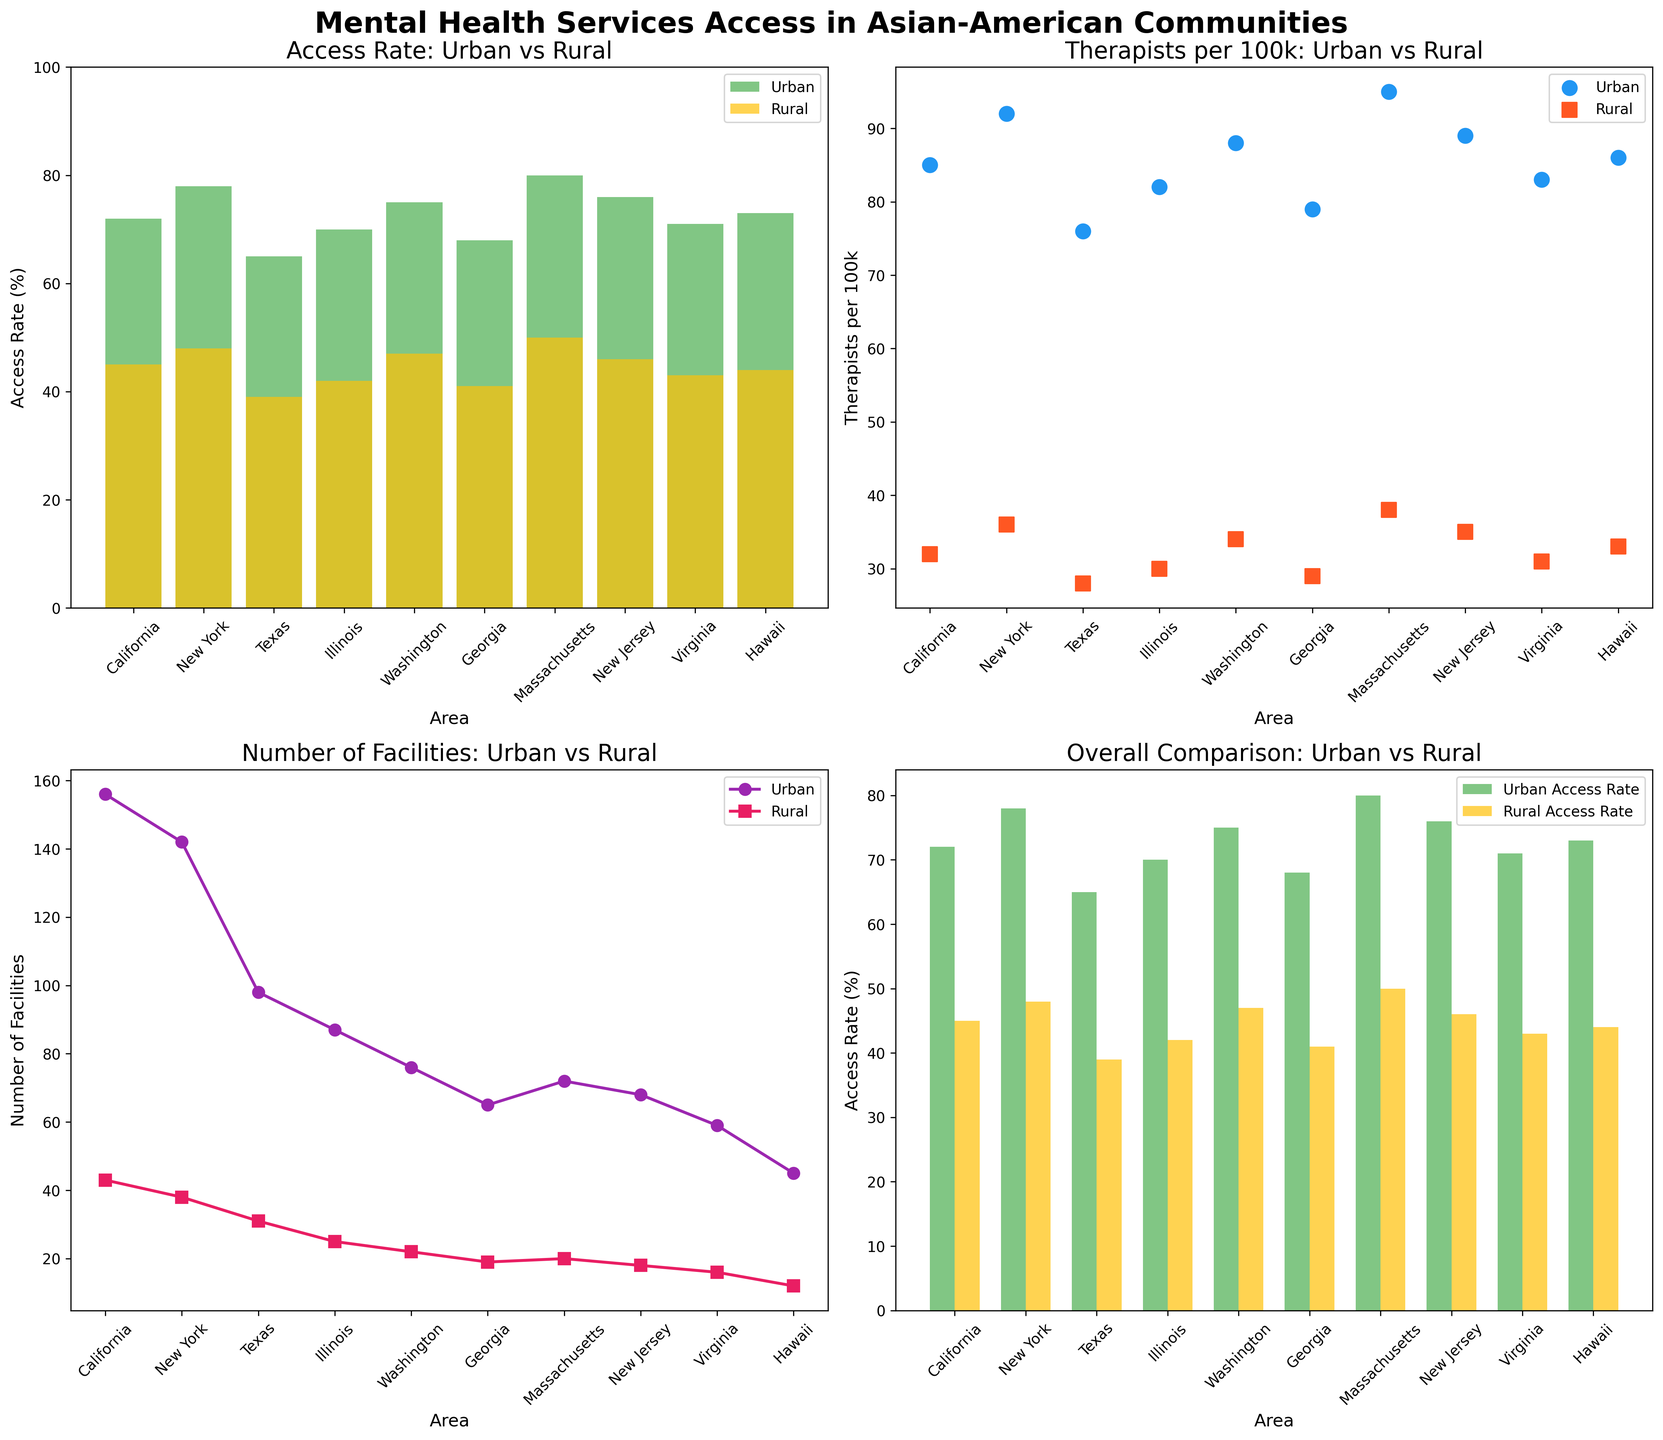What's the title of the overall figure? The title of the overall figure is shown at the top of the entire plot. Simply reading that title will give it to us.
Answer: Mental Health Services Access in Asian-American Communities What does the first subplot compare? The first subplot's title is "Access Rate: Urban vs Rural," indicating it compares the access rate to mental health services in urban versus rural areas.
Answer: Access rate to mental health services in urban vs rural areas How many facilities are there in rural Hawaii compared to urban Hawaii? Looking at the third subplot (bottom left), we can see two points for Hawaii, with one indicating roughly 12 facilities for rural areas and the other 45 for urban areas.
Answer: Urban: 45, Rural: 12 Which area has the highest urban access rate to mental health services? From the first subplot (top left), the highest bar for urban areas corresponds to Massachusetts with an 80% access rate.
Answer: Massachusetts What's the general trend in the number of therapists per 100k between urban and rural areas? Observing the second subplot (top right), it's clear that all urban areas have more therapists per 100k compared to rural areas as all urban markers are higher than the rural markers systematically across different areas.
Answer: Urban areas have more therapists per 100k than rural areas How does the urban access rate compare to the rural access rate in California? Looking at the first subplot, California's bars show an urban access rate of 72% compared to a rural access rate of 45%. We subtract to find the difference: 72% - 45% = 27%.
Answer: Urban access rate is 27% higher In which area is the difference in the number of facilities between urban and rural the smallest? To find this, we look at the third subplot and notice that the smallest vertical distance between the urban and rural lines occurs in Texas, where the difference is 98 - 31 = 67 facilities. The next smallest difference is New Jersey with 68 - 18 = 50 facilities.
Answer: New Jersey Which state has the largest disparity in access rates between urban and rural communities? Comparing the height of bars in the first subplot, Massachusetts has a difference of 80% for urban and 50% for rural, totaling a disparity of 30%. This is the largest disparity observed in the plot.
Answer: Massachusetts Are rural facilities uniformly less than urban facilities across all areas in the third subplot? By carefully examining the third subplot, we see that the number of rural facilities is consistently less than that of urban facilities for all areas plotted.
Answer: Yes Which subplot would you look at to understand the overall comparison of access rates between urban and rural areas in different regions? The fourth subplot (bottom right) titled 'Overall Comparison: Urban vs Rural' focuses on summarizing the access rates in urban and rural areas for all regions, making it the best choice for this overview.
Answer: Fourth subplot (bottom right) 